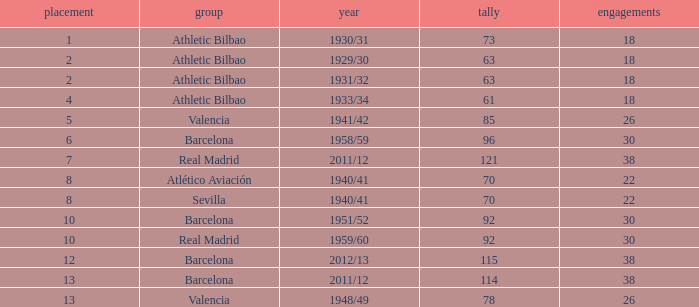What season was Barcelona ranked higher than 12, had more than 96 goals and had more than 26 apps? 2011/12. 